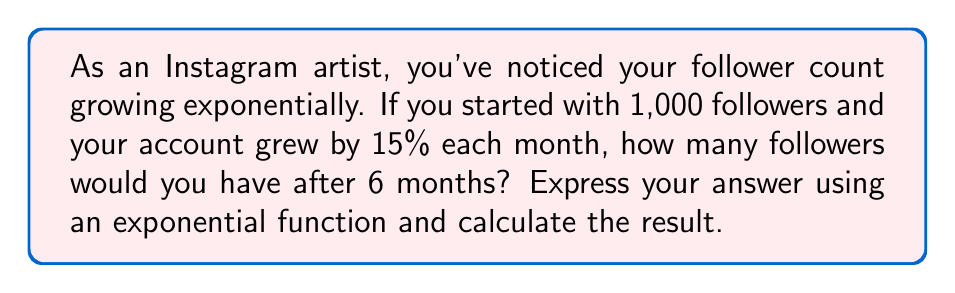Can you solve this math problem? Let's approach this step-by-step:

1) The general form of an exponential growth function is:

   $$A(t) = A_0 \cdot (1 + r)^t$$

   Where:
   $A(t)$ is the amount after time $t$
   $A_0$ is the initial amount
   $r$ is the growth rate (as a decimal)
   $t$ is the time period

2) In this case:
   $A_0 = 1,000$ (initial followers)
   $r = 0.15$ (15% growth rate)
   $t = 6$ (months)

3) Substituting these values into the formula:

   $$A(6) = 1000 \cdot (1 + 0.15)^6$$

4) Simplify inside the parentheses:

   $$A(6) = 1000 \cdot (1.15)^6$$

5) Calculate $(1.15)^6$:

   $$(1.15)^6 \approx 2.3131$$

6) Multiply by 1000:

   $$A(6) = 1000 \cdot 2.3131 \approx 2,313.1$$

7) Since we can't have a fractional follower, we round down to the nearest whole number:

   $$A(6) = 2,313 \text{ followers}$$
Answer: $A(6) = 1000 \cdot (1.15)^6 \approx 2,313$ followers 